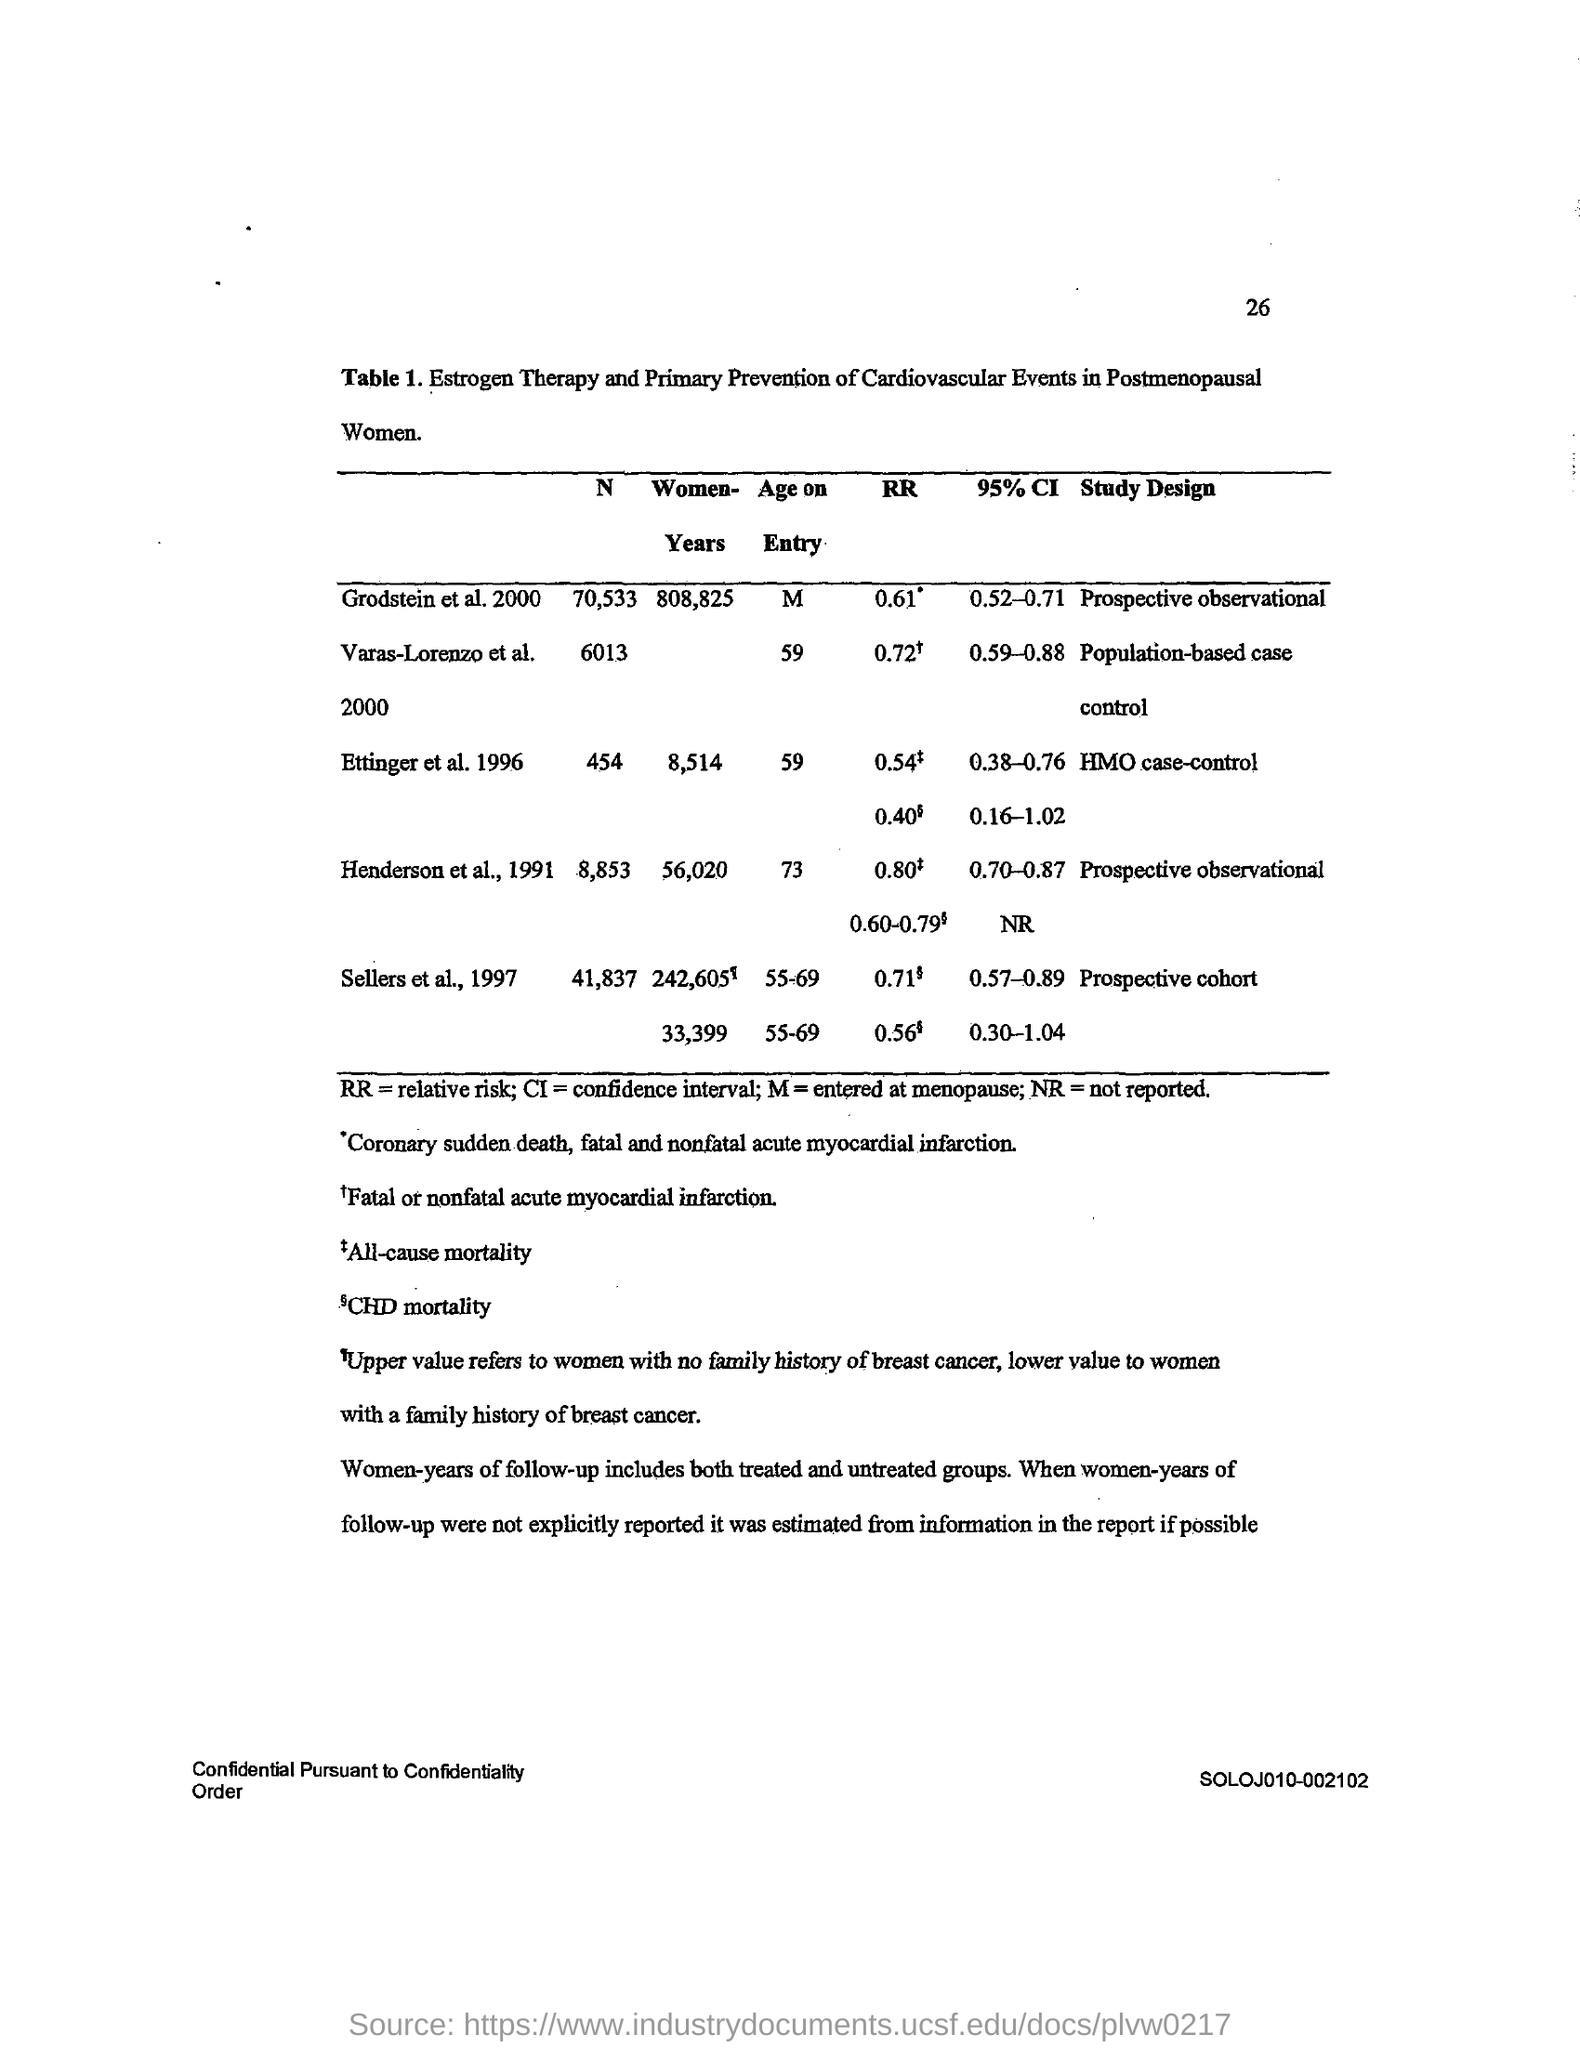What is the Page Number?
Make the answer very short. 26. What is the full form of RR?
Provide a succinct answer. Relative risk. What is the full form of CI?
Your answer should be very brief. Confidence interval. 